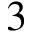Convert formula to latex. <formula><loc_0><loc_0><loc_500><loc_500>3</formula> 